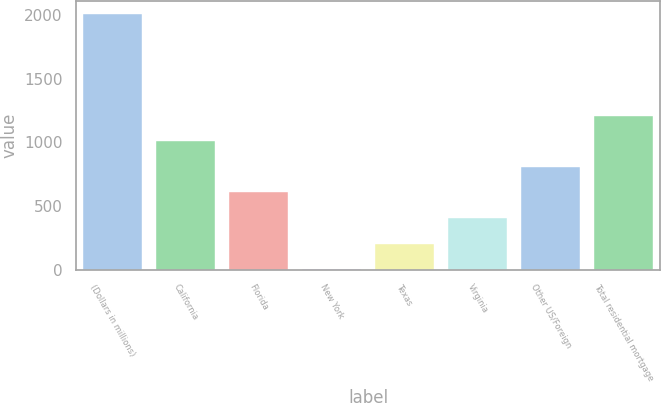Convert chart to OTSL. <chart><loc_0><loc_0><loc_500><loc_500><bar_chart><fcel>(Dollars in millions)<fcel>California<fcel>Florida<fcel>New York<fcel>Texas<fcel>Virginia<fcel>Other US/Foreign<fcel>Total residential mortgage<nl><fcel>2008<fcel>1006.5<fcel>605.9<fcel>5<fcel>205.3<fcel>405.6<fcel>806.2<fcel>1206.8<nl></chart> 